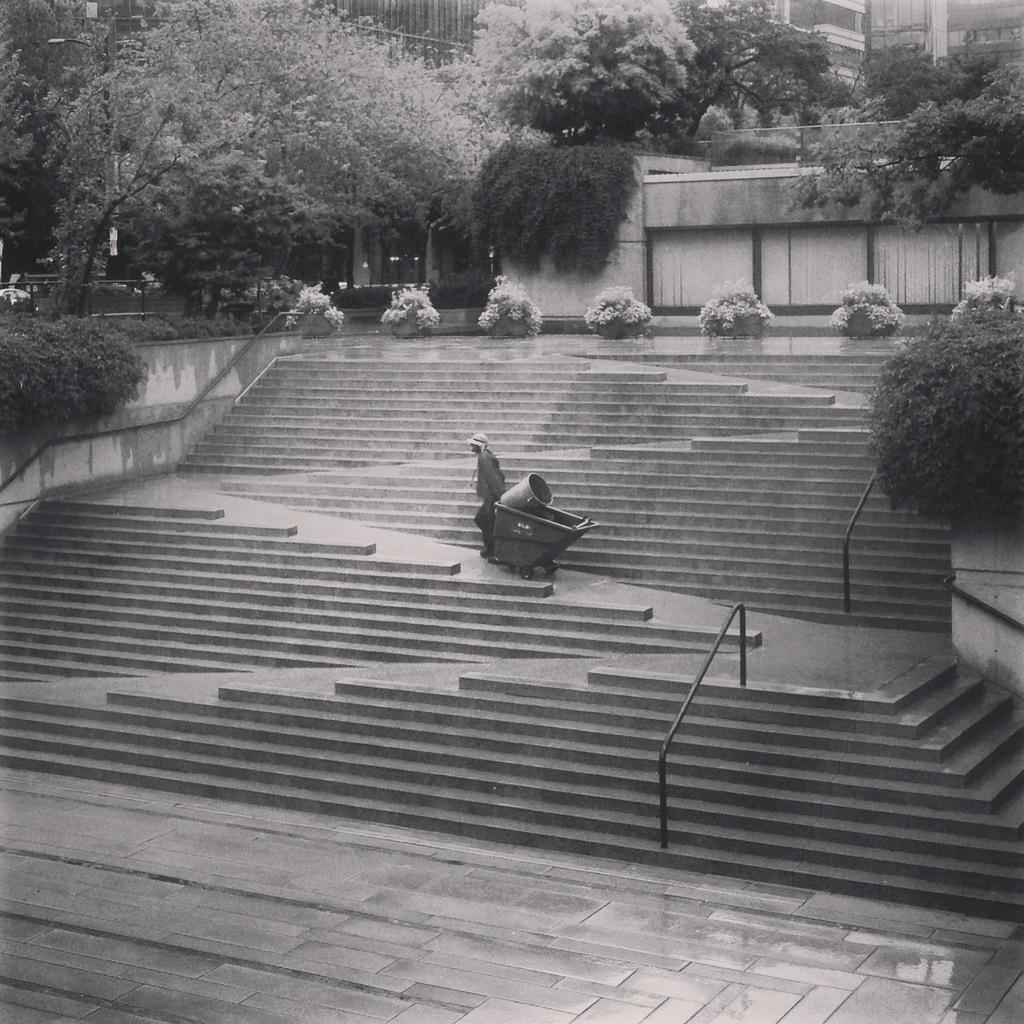Describe this image in one or two sentences. In this black and white image there is a person holding a trolley and walking on the stairs. In the background there are buildings and trees. 